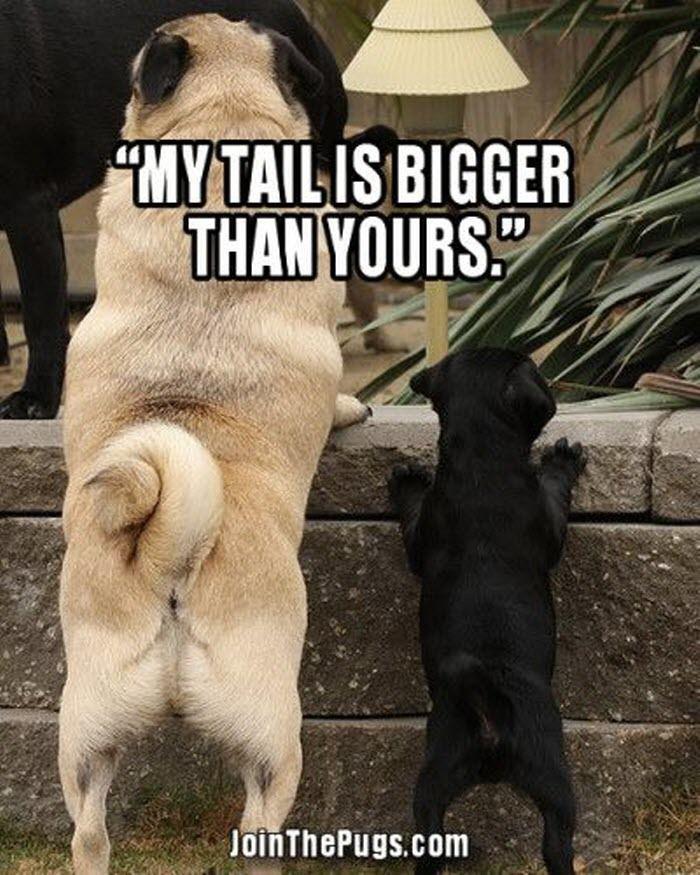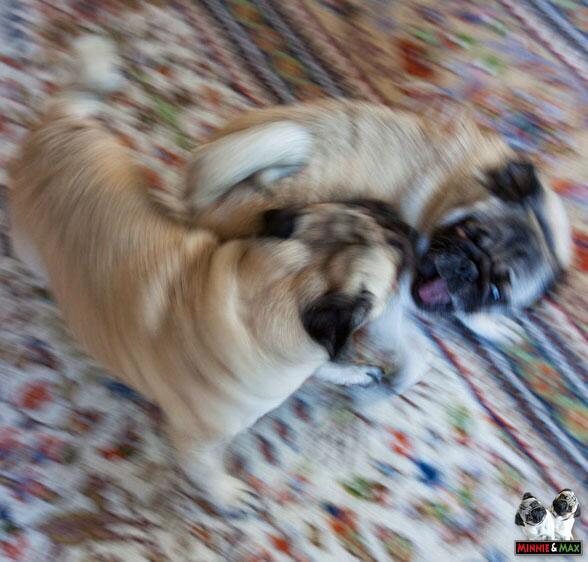The first image is the image on the left, the second image is the image on the right. Given the left and right images, does the statement "There is two dogs in the right image." hold true? Answer yes or no. Yes. The first image is the image on the left, the second image is the image on the right. Considering the images on both sides, is "One image shows a smaller black dog next to a buff-beige pug." valid? Answer yes or no. Yes. 